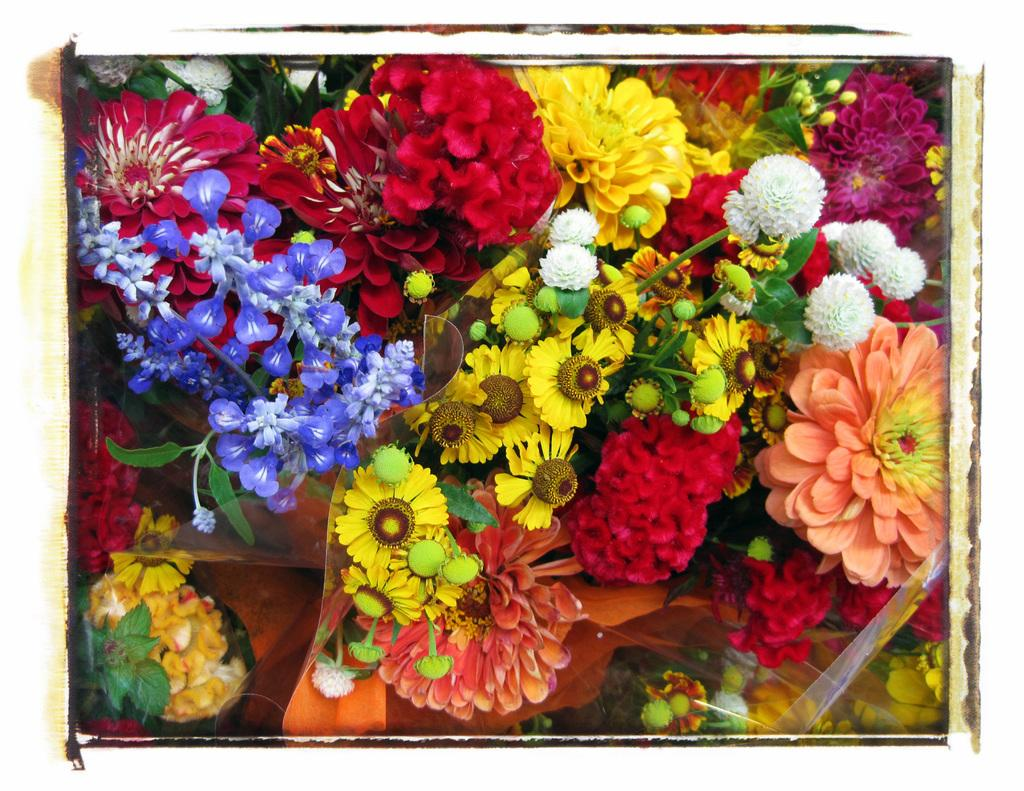What type of objects are present in the image? There are bouquets of flowers in the image. Can you describe the flowers in the bouquets? The specific types of flowers in the bouquets cannot be determined from the image. How many bouquets of flowers are visible in the image? The exact number of bouquets cannot be determined from the image, but there are multiple bouquets present. What type of teaching method is being demonstrated by the giants in the image? There are no giants or teaching methods present in the image; it only features bouquets of flowers. 